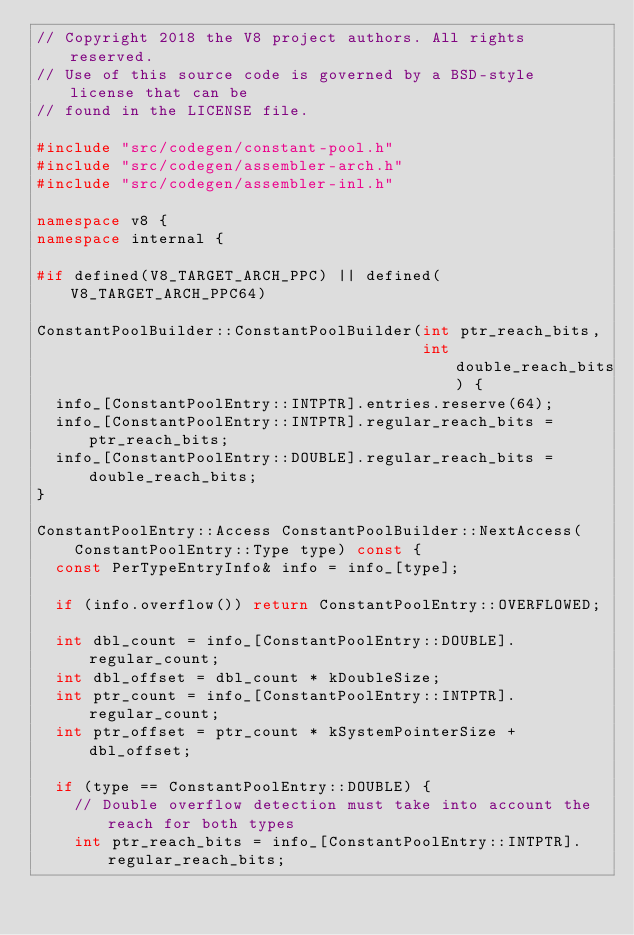Convert code to text. <code><loc_0><loc_0><loc_500><loc_500><_C++_>// Copyright 2018 the V8 project authors. All rights reserved.
// Use of this source code is governed by a BSD-style license that can be
// found in the LICENSE file.

#include "src/codegen/constant-pool.h"
#include "src/codegen/assembler-arch.h"
#include "src/codegen/assembler-inl.h"

namespace v8 {
namespace internal {

#if defined(V8_TARGET_ARCH_PPC) || defined(V8_TARGET_ARCH_PPC64)

ConstantPoolBuilder::ConstantPoolBuilder(int ptr_reach_bits,
                                         int double_reach_bits) {
  info_[ConstantPoolEntry::INTPTR].entries.reserve(64);
  info_[ConstantPoolEntry::INTPTR].regular_reach_bits = ptr_reach_bits;
  info_[ConstantPoolEntry::DOUBLE].regular_reach_bits = double_reach_bits;
}

ConstantPoolEntry::Access ConstantPoolBuilder::NextAccess(
    ConstantPoolEntry::Type type) const {
  const PerTypeEntryInfo& info = info_[type];

  if (info.overflow()) return ConstantPoolEntry::OVERFLOWED;

  int dbl_count = info_[ConstantPoolEntry::DOUBLE].regular_count;
  int dbl_offset = dbl_count * kDoubleSize;
  int ptr_count = info_[ConstantPoolEntry::INTPTR].regular_count;
  int ptr_offset = ptr_count * kSystemPointerSize + dbl_offset;

  if (type == ConstantPoolEntry::DOUBLE) {
    // Double overflow detection must take into account the reach for both types
    int ptr_reach_bits = info_[ConstantPoolEntry::INTPTR].regular_reach_bits;</code> 